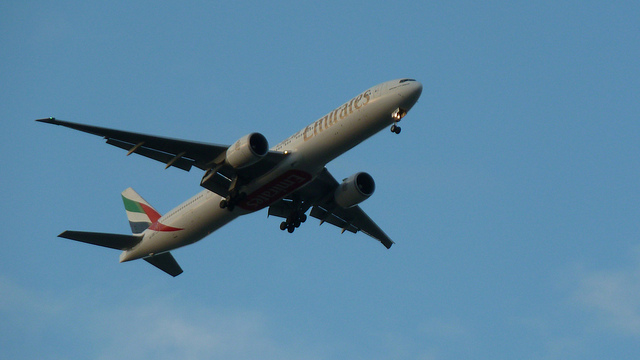<image>What is the name of this travel company? I don't know the name of this travel company. It might be 'emirates' or 'eurates'. What type of jet plane is this? It is unknown what type of jet plane this is. It can be 'jumbo jet', 'emirates', 'presidential', 'commercial', or 'jet'. What is the name of this travel company? I don't know what is the name of this travel company. What type of jet plane is this? It is unknown what type of jet plane this is. It can be seen as 'emirates', 'jumbo jet', 'commercial' or 'presidential'. 